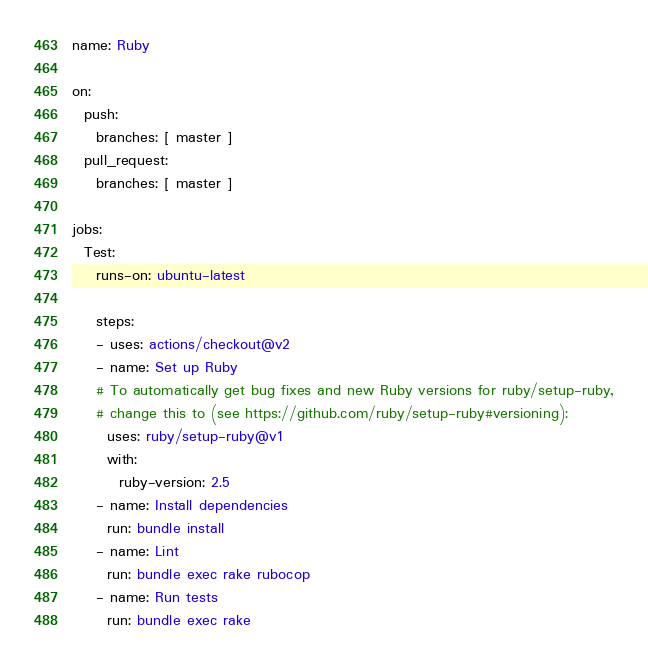Convert code to text. <code><loc_0><loc_0><loc_500><loc_500><_YAML_>name: Ruby

on:
  push:
    branches: [ master ]
  pull_request:
    branches: [ master ]

jobs:
  Test:
    runs-on: ubuntu-latest

    steps:
    - uses: actions/checkout@v2
    - name: Set up Ruby
    # To automatically get bug fixes and new Ruby versions for ruby/setup-ruby,
    # change this to (see https://github.com/ruby/setup-ruby#versioning):
      uses: ruby/setup-ruby@v1
      with:
        ruby-version: 2.5
    - name: Install dependencies
      run: bundle install
    - name: Lint
      run: bundle exec rake rubocop
    - name: Run tests
      run: bundle exec rake
</code> 